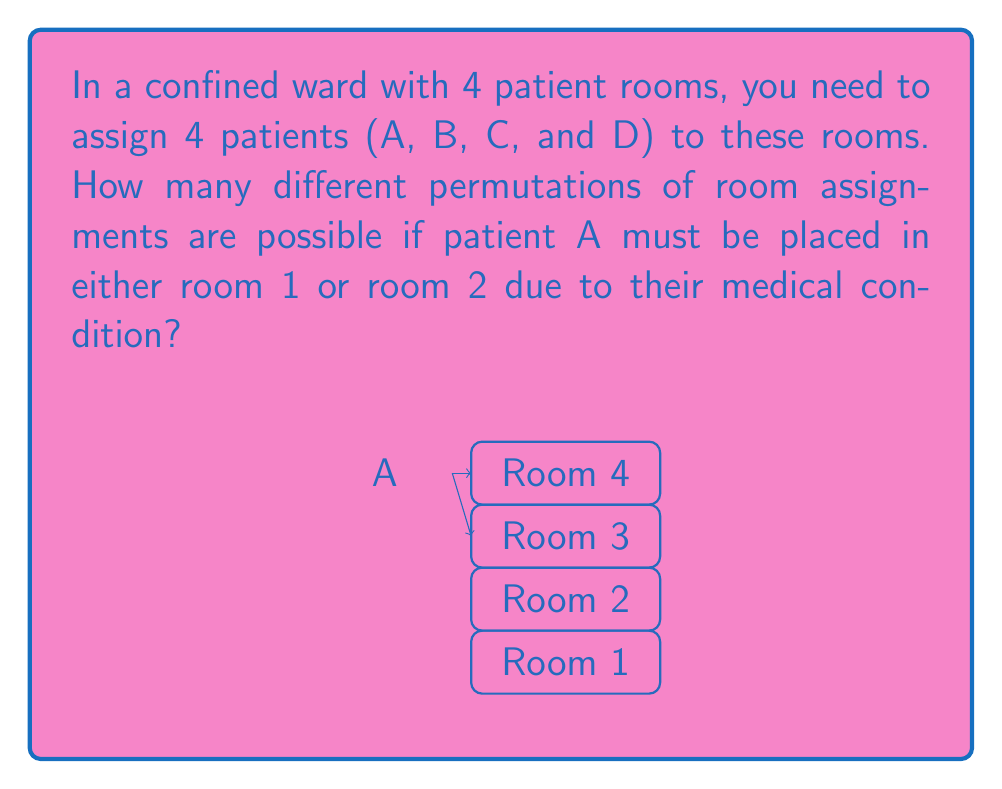Teach me how to tackle this problem. Let's approach this step-by-step:

1) First, we need to consider the restriction on patient A. They can only be in room 1 or room 2. This gives us two cases to consider.

2) Case 1: Patient A in room 1
   - A is fixed in room 1
   - We now need to arrange B, C, and D in the remaining 3 rooms
   - This is a permutation of 3 elements, which is $3! = 3 \times 2 \times 1 = 6$

3) Case 2: Patient A in room 2
   - A is fixed in room 2
   - Again, we need to arrange B, C, and D in the remaining 3 rooms
   - This is also a permutation of 3 elements, which is $3! = 6$

4) By the addition principle, we sum the number of permutations from each case:
   $6 + 6 = 12$

5) We can also express this using permutation notation:
   $2 \times P(3,3) = 2 \times 3! = 2 \times 6 = 12$

   Where $2$ represents the two choices for A's room, and $P(3,3)$ represents the permutation of the other 3 patients in the remaining 3 rooms.

Therefore, there are 12 different permutations of room assignments possible under these conditions.
Answer: 12 permutations 